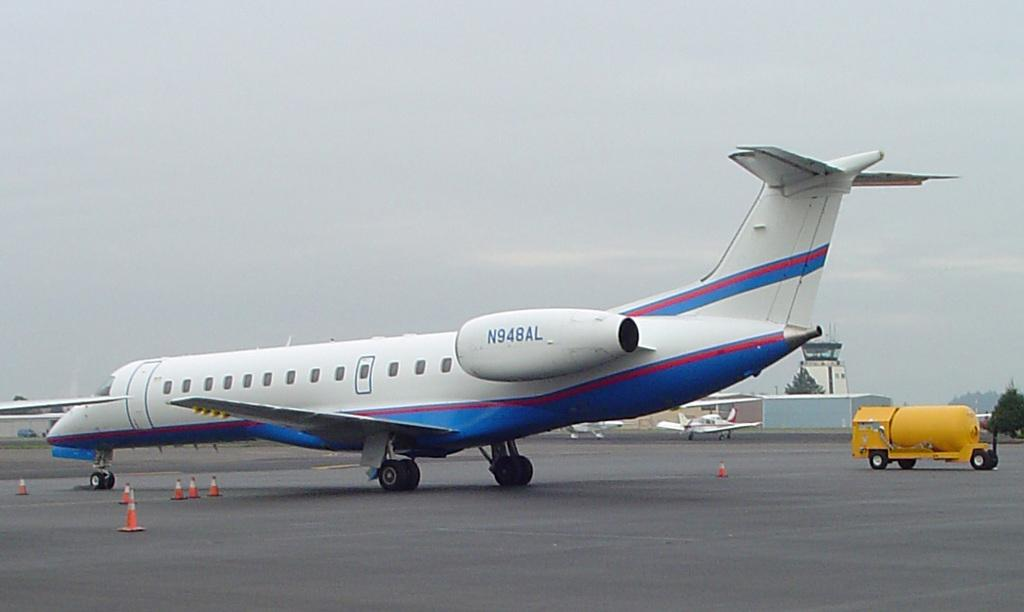<image>
Offer a succinct explanation of the picture presented. a small white plane on the tarmac with N948AL on its side 